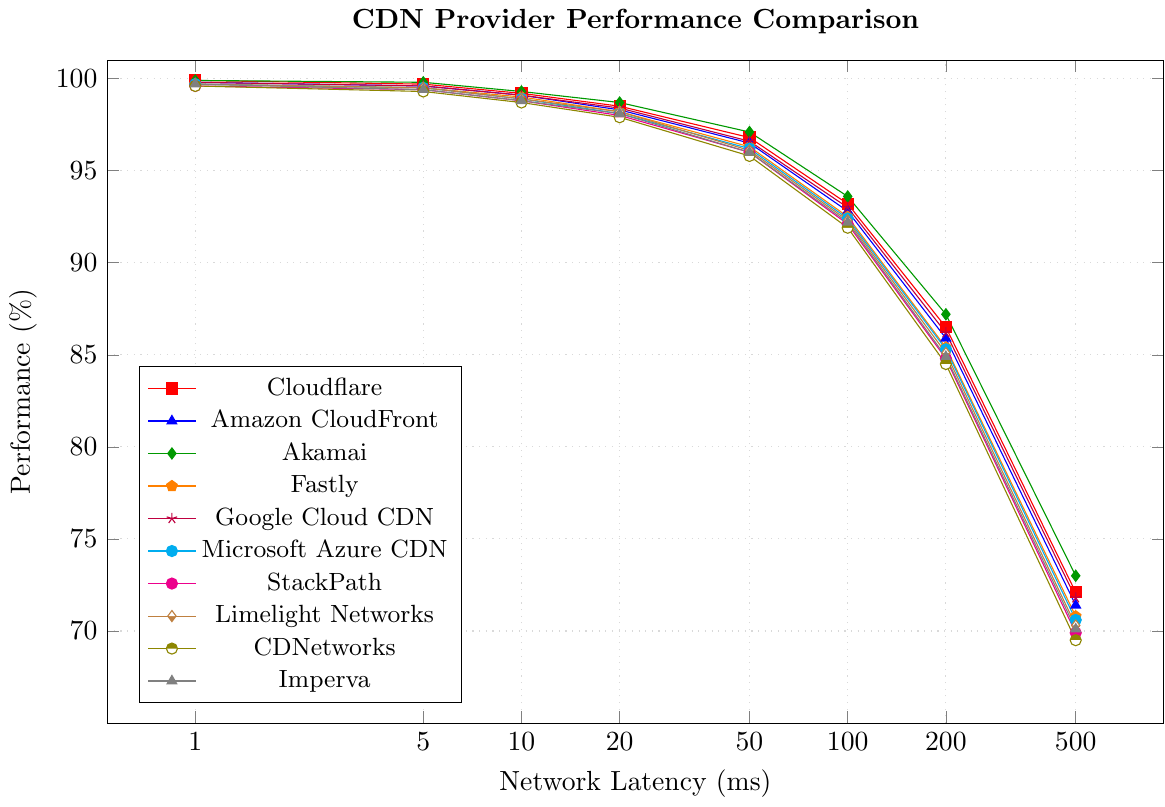Which CDN provider maintains the highest performance at 100ms latency? To find this, look at the plot and identify the line with the highest y-axis value at the 100ms x-axis mark. Akamai has the highest performance of 93.6% at 100ms latency.
Answer: Akamai How does the performance difference between Cloudflare and Amazon CloudFront at 500ms latency compare to their difference at 5ms? First, find the performance values for both CDN providers at 500ms and 5ms. At 500ms, Cloudflare is at 72.1% and Amazon CloudFront is at 71.4%, so the difference is 0.7%. At 5ms, Cloudflare is at 99.7% and Amazon CloudFront is at 99.6%, so the difference is 0.1%. Subtracting these differences shows the change in performance difference over the latencies.
Answer: 0.6% Which CDN provider shows the greatest decline in performance from 1ms to 500ms? Calculate the performance drop for each CDN provider from 1ms to 500ms. For example, Cloudflare drops from 99.9% to 72.1%, so a 27.8% drop. Perform these calculations for all providers and compare the results. Akamai drops from 99.9% to 73.0%, a difference of 26.9%. Therefore, Cloudflare has the greatest decline.
Answer: Cloudflare Is Google Cloud CDN ever the top performer compared to Akamai? Compare the performance values between Google Cloud CDN and Akamai across all latency points. Akamai consistently has higher or equal values compared to Google Cloud CDN at every latency point. Therefore, Google Cloud CDN never outperforms Akamai.
Answer: No At what latency does Microsoft Azure CDN cross below 85% performance? Check the performance values of Microsoft Azure CDN at increasing latencies until it falls below 85%. At 200ms, Microsoft Azure CDN shows a performance of 85.3%, and at 500ms, it drops to 70.6%. Hence, it first crosses below 85% between 200ms and 500ms.
Answer: Between 200ms and 500ms Which CDN providers maintain performance above 90% up to 50ms latency? Identify the performance values at 50ms for all CDN providers and check if they are above 90%. Cloudflare, Amazon CloudFront, Akamai, Google Cloud CDN, Fastly, and Microsoft Azure CDN all have performance values above 90% at 50ms.
Answer: Cloudflare, Amazon CloudFront, Akamai, Google Cloud CDN, Fastly, and Microsoft Azure CDN How does the performance of Fastly at 20ms compare to CDNetworks at 100ms? Find the performance values of Fastly at 20ms and CDNetworks at 100ms. Fastly has 98.2% performance at 20ms. CDNetworks has 91.9% performance at 100ms.
Answer: Fastly at 20ms performs 6.3% better At a latency of 10ms, which CDN provider performs slightly better than Microsoft Azure CDN? Look for the performance value of Microsoft Azure CDN at 10ms, which is 98.9%. Cloudflare, Amazon CloudFront, Google Cloud CDN, and Akamai all perform better than 98.9%, but the one that performs slightly better is Google Cloud CDN at 99.1%.
Answer: Google Cloud CDN Does Limelight Networks ever outperform Fastly? Compare the performance values of Limelight Networks and Fastly at each latency point. At each data point, Limelight Networks never exceeds the performance of Fastly.
Answer: No What is the average performance of StackPath from 1ms to 500ms? Sum the performance values of StackPath across all the given latency points (99.6 + 99.4 + 98.8 + 98.0 + 96.0 + 92.1 + 84.8 + 69.9) and divide by the number of points, which is 8. The total is 738.6, so the average is 738.6 / 8 = 92.325.
Answer: 92.325% 